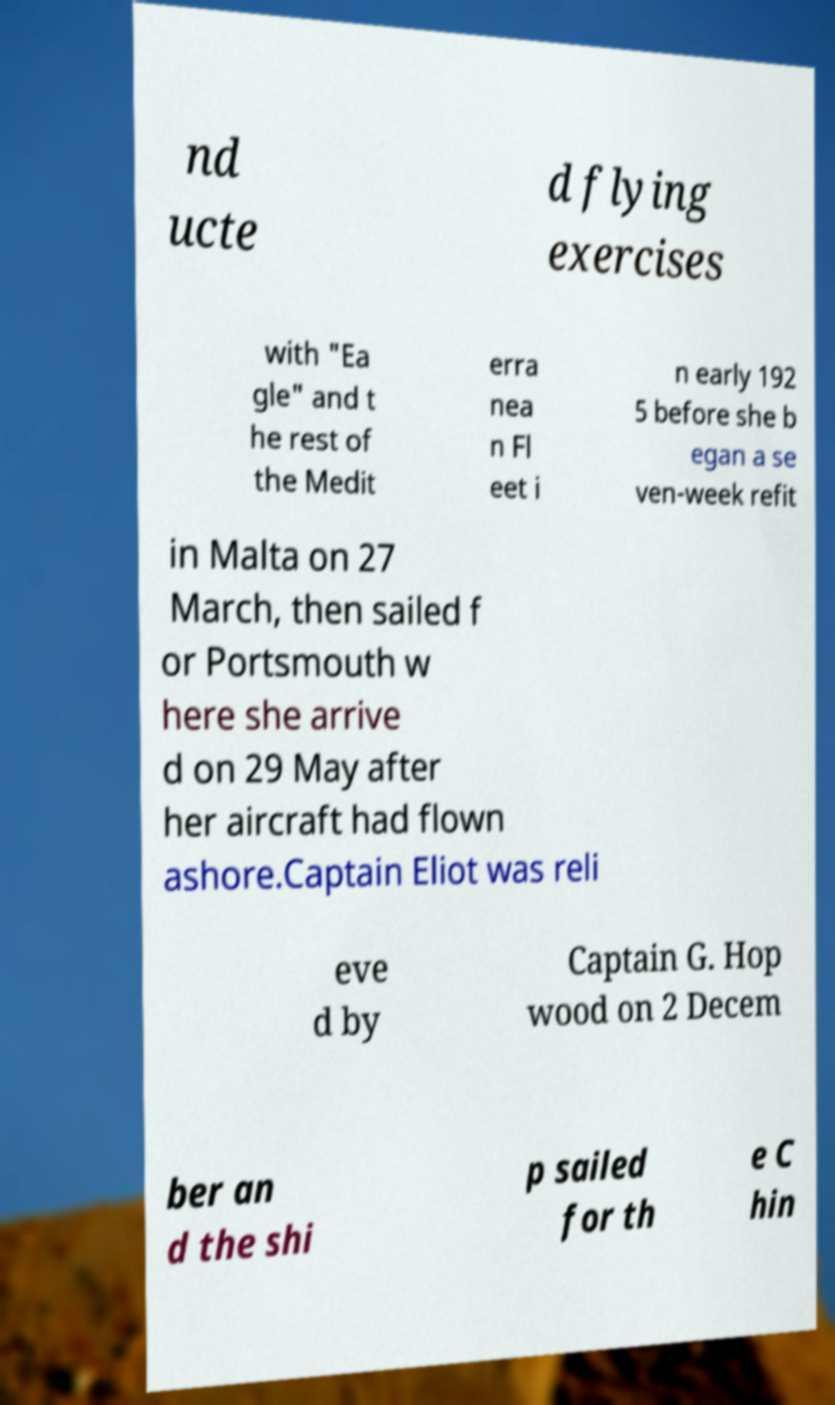Can you read and provide the text displayed in the image?This photo seems to have some interesting text. Can you extract and type it out for me? nd ucte d flying exercises with "Ea gle" and t he rest of the Medit erra nea n Fl eet i n early 192 5 before she b egan a se ven-week refit in Malta on 27 March, then sailed f or Portsmouth w here she arrive d on 29 May after her aircraft had flown ashore.Captain Eliot was reli eve d by Captain G. Hop wood on 2 Decem ber an d the shi p sailed for th e C hin 